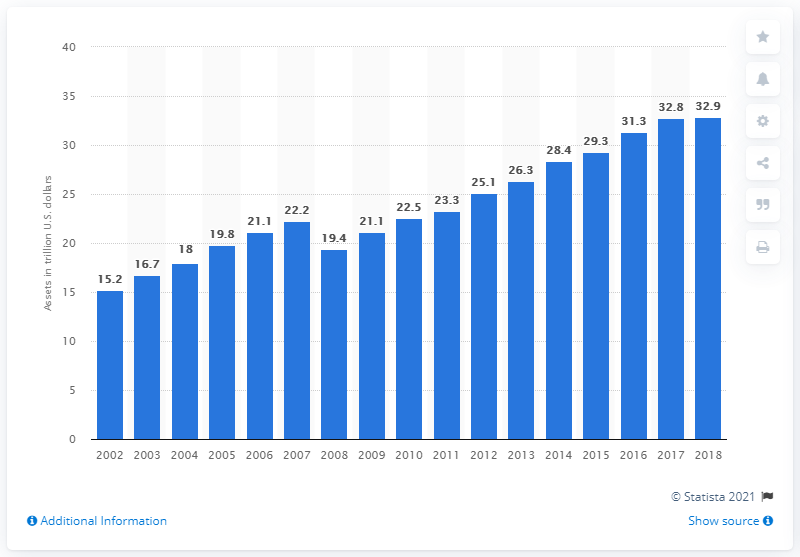Draw attention to some important aspects in this diagram. In the year 2018, the value of assets held by insurance companies globally was approximately 32.9 trillion dollars. 